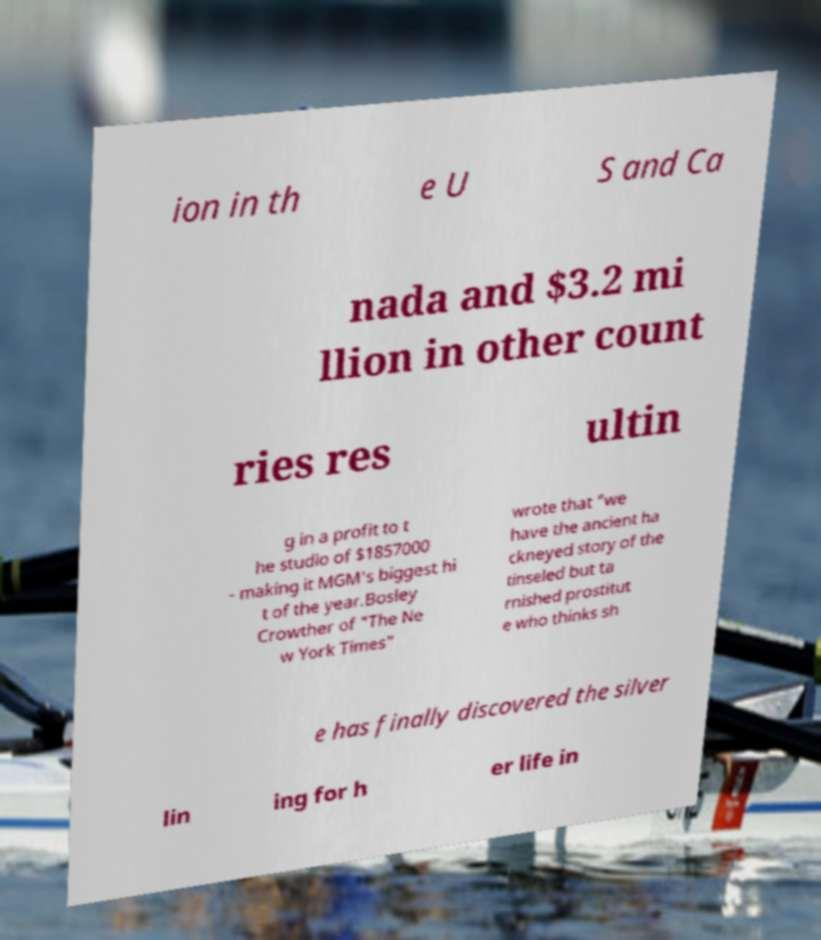Could you extract and type out the text from this image? ion in th e U S and Ca nada and $3.2 mi llion in other count ries res ultin g in a profit to t he studio of $1857000 - making it MGM's biggest hi t of the year.Bosley Crowther of "The Ne w York Times" wrote that "we have the ancient ha ckneyed story of the tinseled but ta rnished prostitut e who thinks sh e has finally discovered the silver lin ing for h er life in 